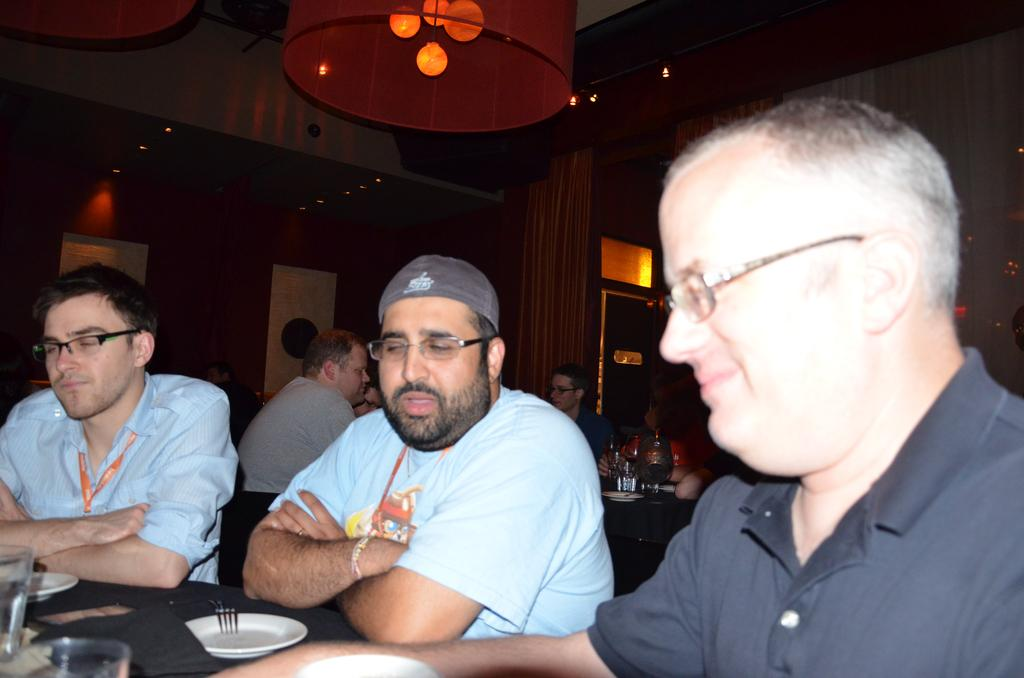What is happening in the image? There are people sitting around a table in the image. What can be seen on the table? There are plates and spoons on the table. Are there any other items on the table? Yes, there are other things on the table. What is hanging from the ceiling in the image? There is a chandelier hanging from the ceiling. What type of adjustment is being made to the plate in the image? There is no adjustment being made to the plate in the image; it is simply sitting on the table. 